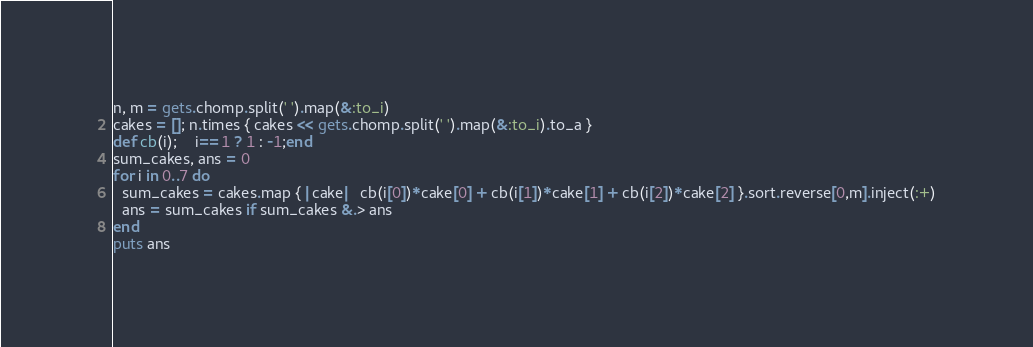Convert code to text. <code><loc_0><loc_0><loc_500><loc_500><_Ruby_>n, m = gets.chomp.split(' ').map(&:to_i)
cakes = []; n.times { cakes << gets.chomp.split(' ').map(&:to_i).to_a } 
def cb(i);	i==1 ? 1 : -1;end
sum_cakes, ans = 0
for i in 0..7 do
  sum_cakes = cakes.map { |cake|  cb(i[0])*cake[0] + cb(i[1])*cake[1] + cb(i[2])*cake[2] }.sort.reverse[0,m].inject(:+)
  ans = sum_cakes if sum_cakes &.> ans
end
puts ans</code> 